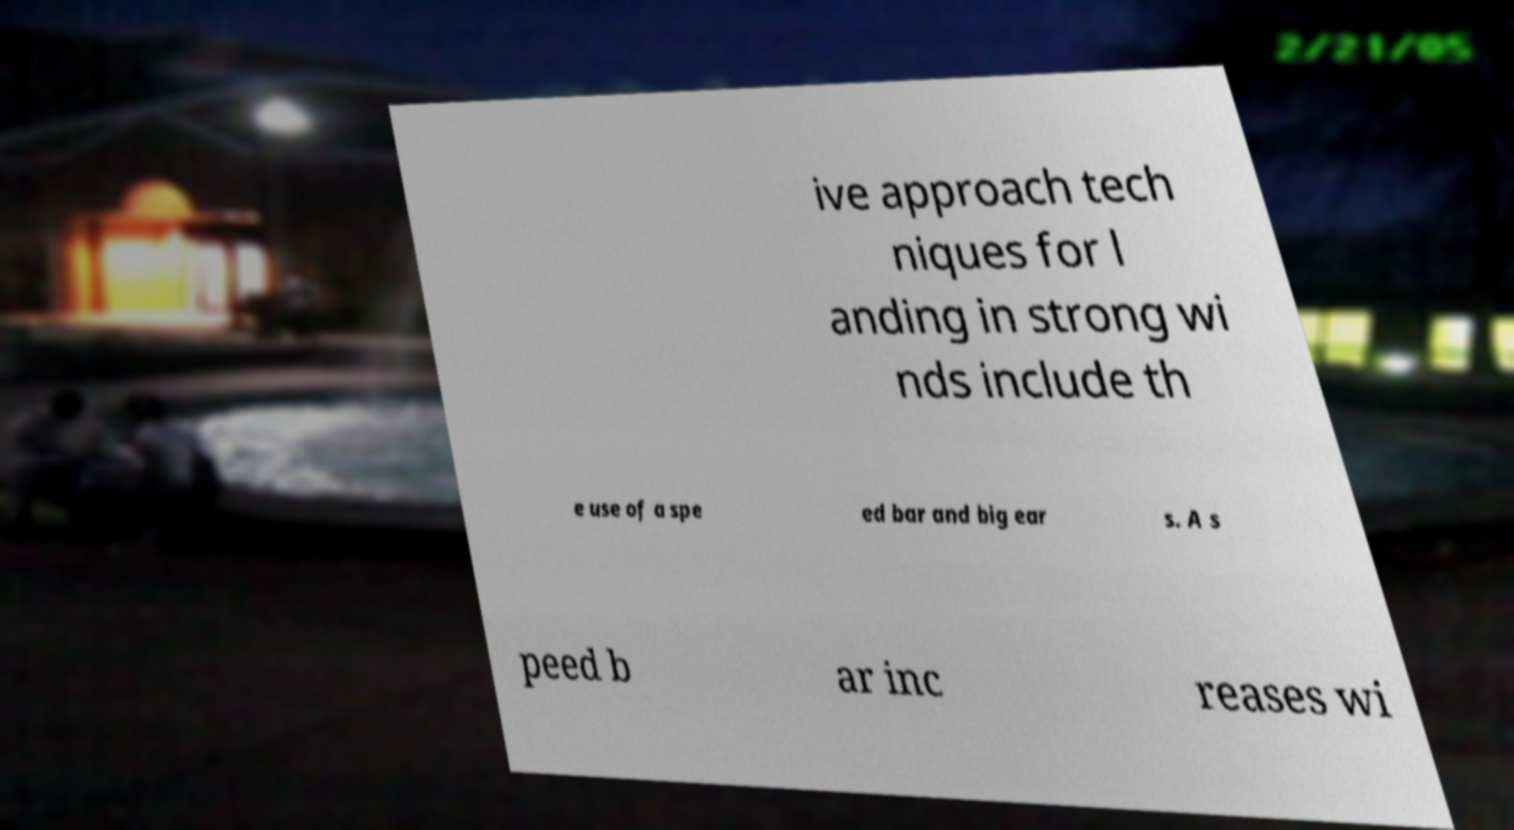Please read and relay the text visible in this image. What does it say? ive approach tech niques for l anding in strong wi nds include th e use of a spe ed bar and big ear s. A s peed b ar inc reases wi 